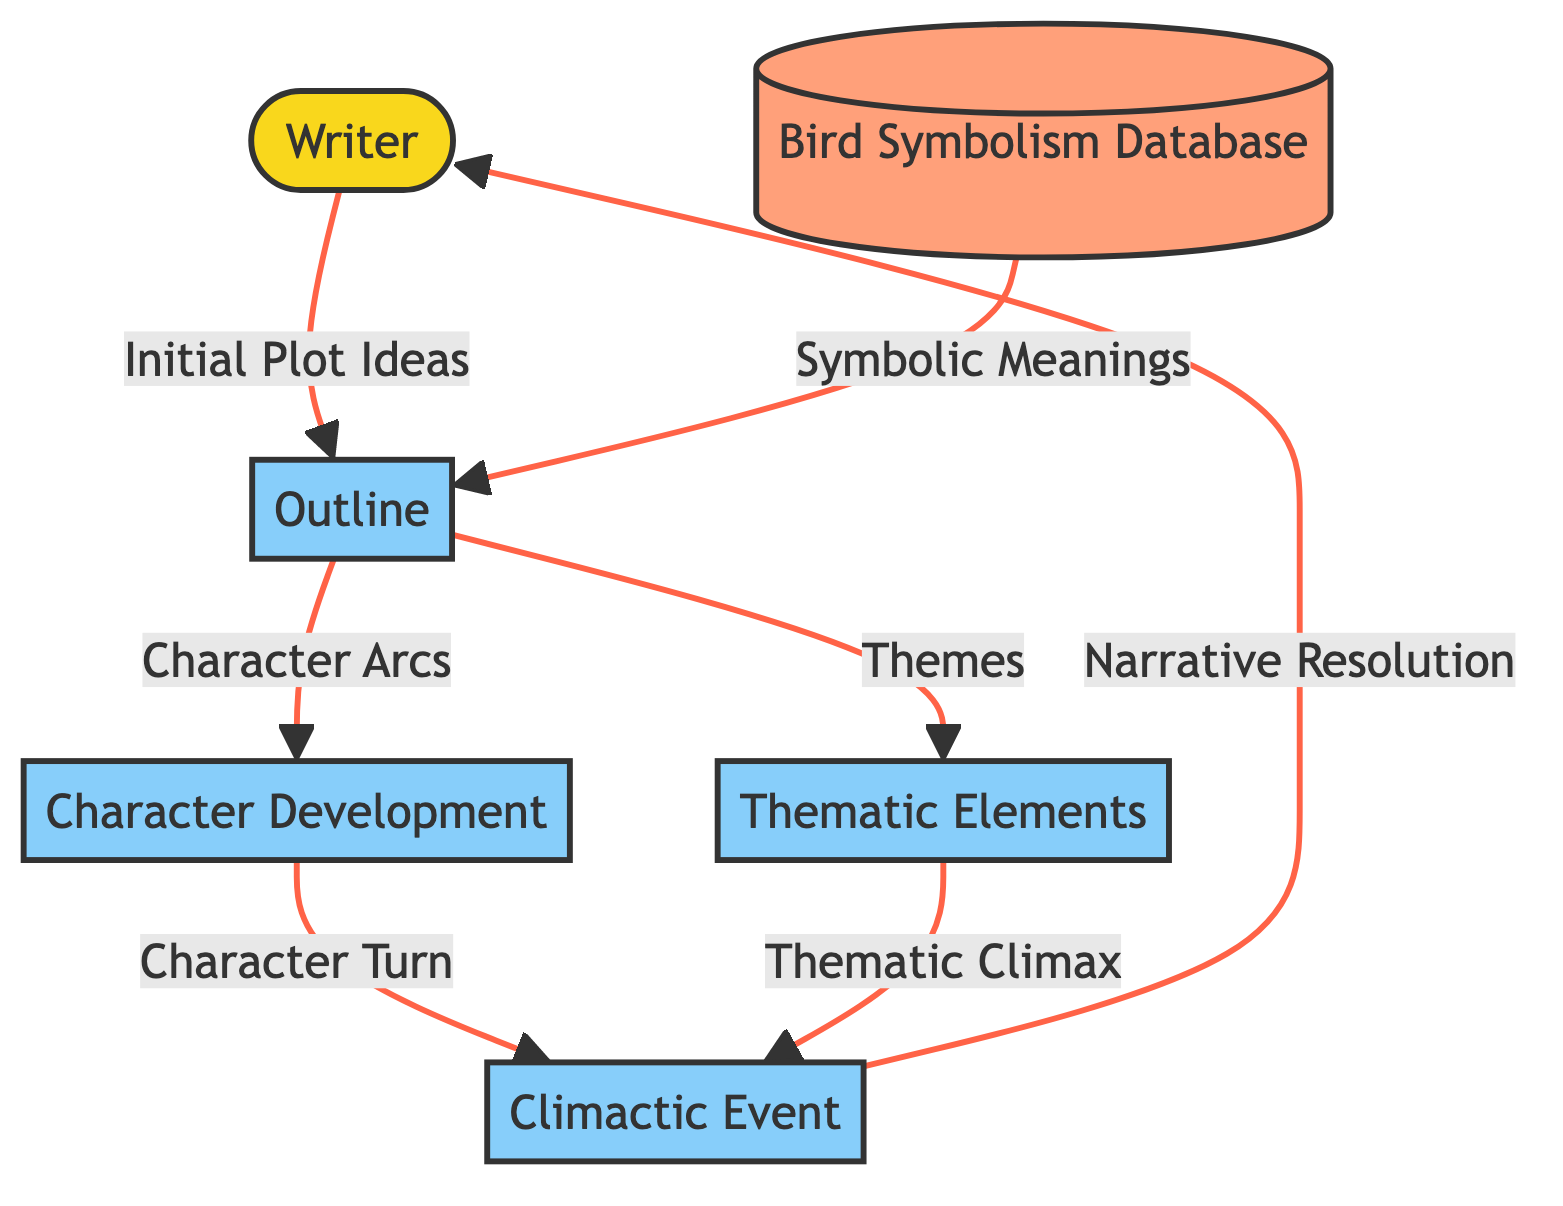What is the initial entity in the diagram? The first node in the diagram represents the "Writer," indicating that the author initiates the process.
Answer: Writer How many process nodes are present in the diagram? There are four process nodes: Outline, Climactic Event, Character Development, and Thematic Elements.
Answer: 4 What is the data flow from the Writer to the Outline? The Writer provides "Initial Plot Ideas" to the Outline, which starts the development process.
Answer: Initial Plot Ideas Which entity receives data from the Bird Symbolism Database? The Outline receives data from the Bird Symbolism Database in the form of "Symbolic Meanings."
Answer: Outline What is the relationship between Thematic Elements and Climactic Event? Thematic Elements flow into the Climactic Event, influencing it with "Thematic Climax."
Answer: Thematic Climax What type of entity is the Bird Symbolism Database? The Bird Symbolism Database is classified as a data store, which holds information for reference.
Answer: data store How do character arcs originate in the diagram? Character arcs are derived from the Outline, indicating how character development is planned based on the initial plot.
Answer: Character Arcs What is the final output of the flow from the Climactic Event to the Writer? The final output is "Narrative Resolution," which provides closure based on the climactic developments.
Answer: Narrative Resolution Which process node leads to the Climactic Event through Character Development? Character Development leads to the Climactic Event, showcasing how character changes contribute to the climax.
Answer: Character Turn What are the themes explored in the narrative associated with the Outline? The Outline is associated with "Themes," identifying the central ideas that will be explored in the story.
Answer: Themes 